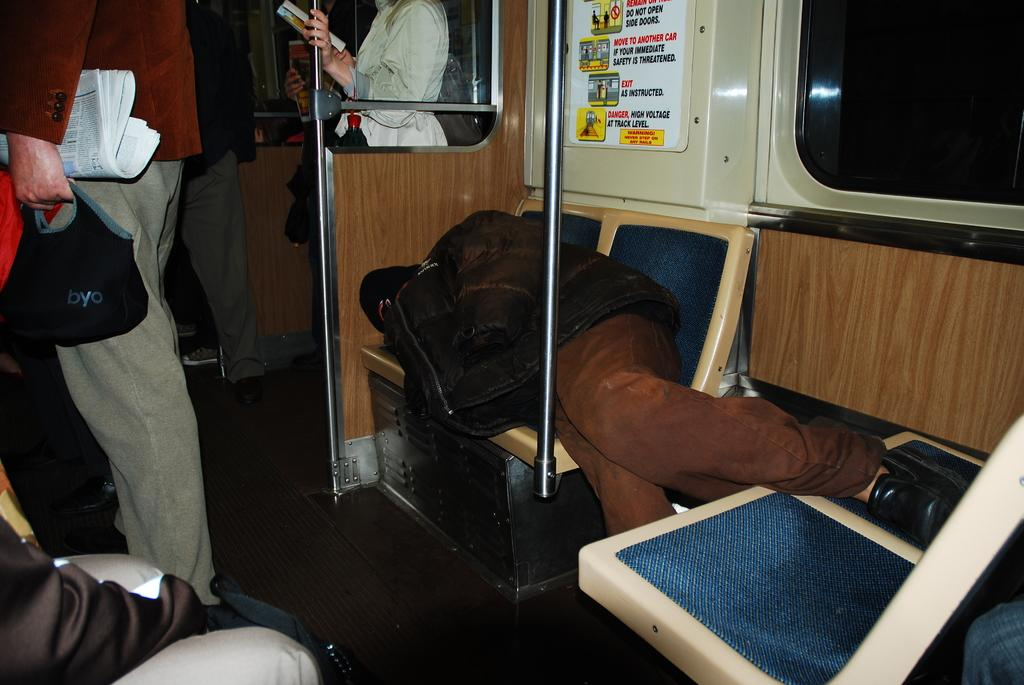What is the position of the person in the image? There is a person laying on a seat in the image. What is located behind the person? There is a poster behind the person. Can you describe the surroundings of the person? The person is in front of a pole, and there are other people in the image. What are some of the other people doing in the image? Some of the other people are holding something in the image. What type of needle can be seen in the image? There is no needle present in the image. How does the thunder affect the people in the image? There is no thunder present in the image, so it does not affect the people. 